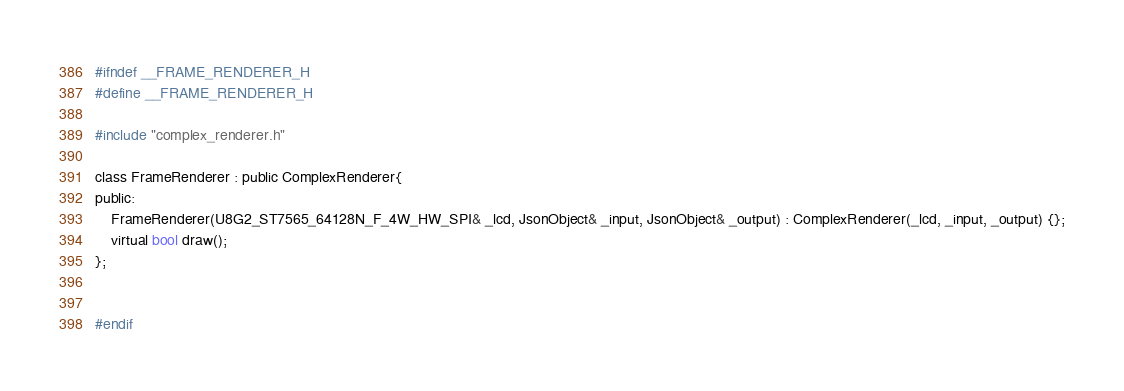Convert code to text. <code><loc_0><loc_0><loc_500><loc_500><_C_>#ifndef __FRAME_RENDERER_H
#define __FRAME_RENDERER_H

#include "complex_renderer.h"

class FrameRenderer : public ComplexRenderer{
public:
    FrameRenderer(U8G2_ST7565_64128N_F_4W_HW_SPI& _lcd, JsonObject& _input, JsonObject& _output) : ComplexRenderer(_lcd, _input, _output) {};
    virtual bool draw();
};


#endif</code> 